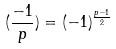<formula> <loc_0><loc_0><loc_500><loc_500>( \frac { - 1 } { p } ) = ( - 1 ) ^ { \frac { p - 1 } { 2 } }</formula> 